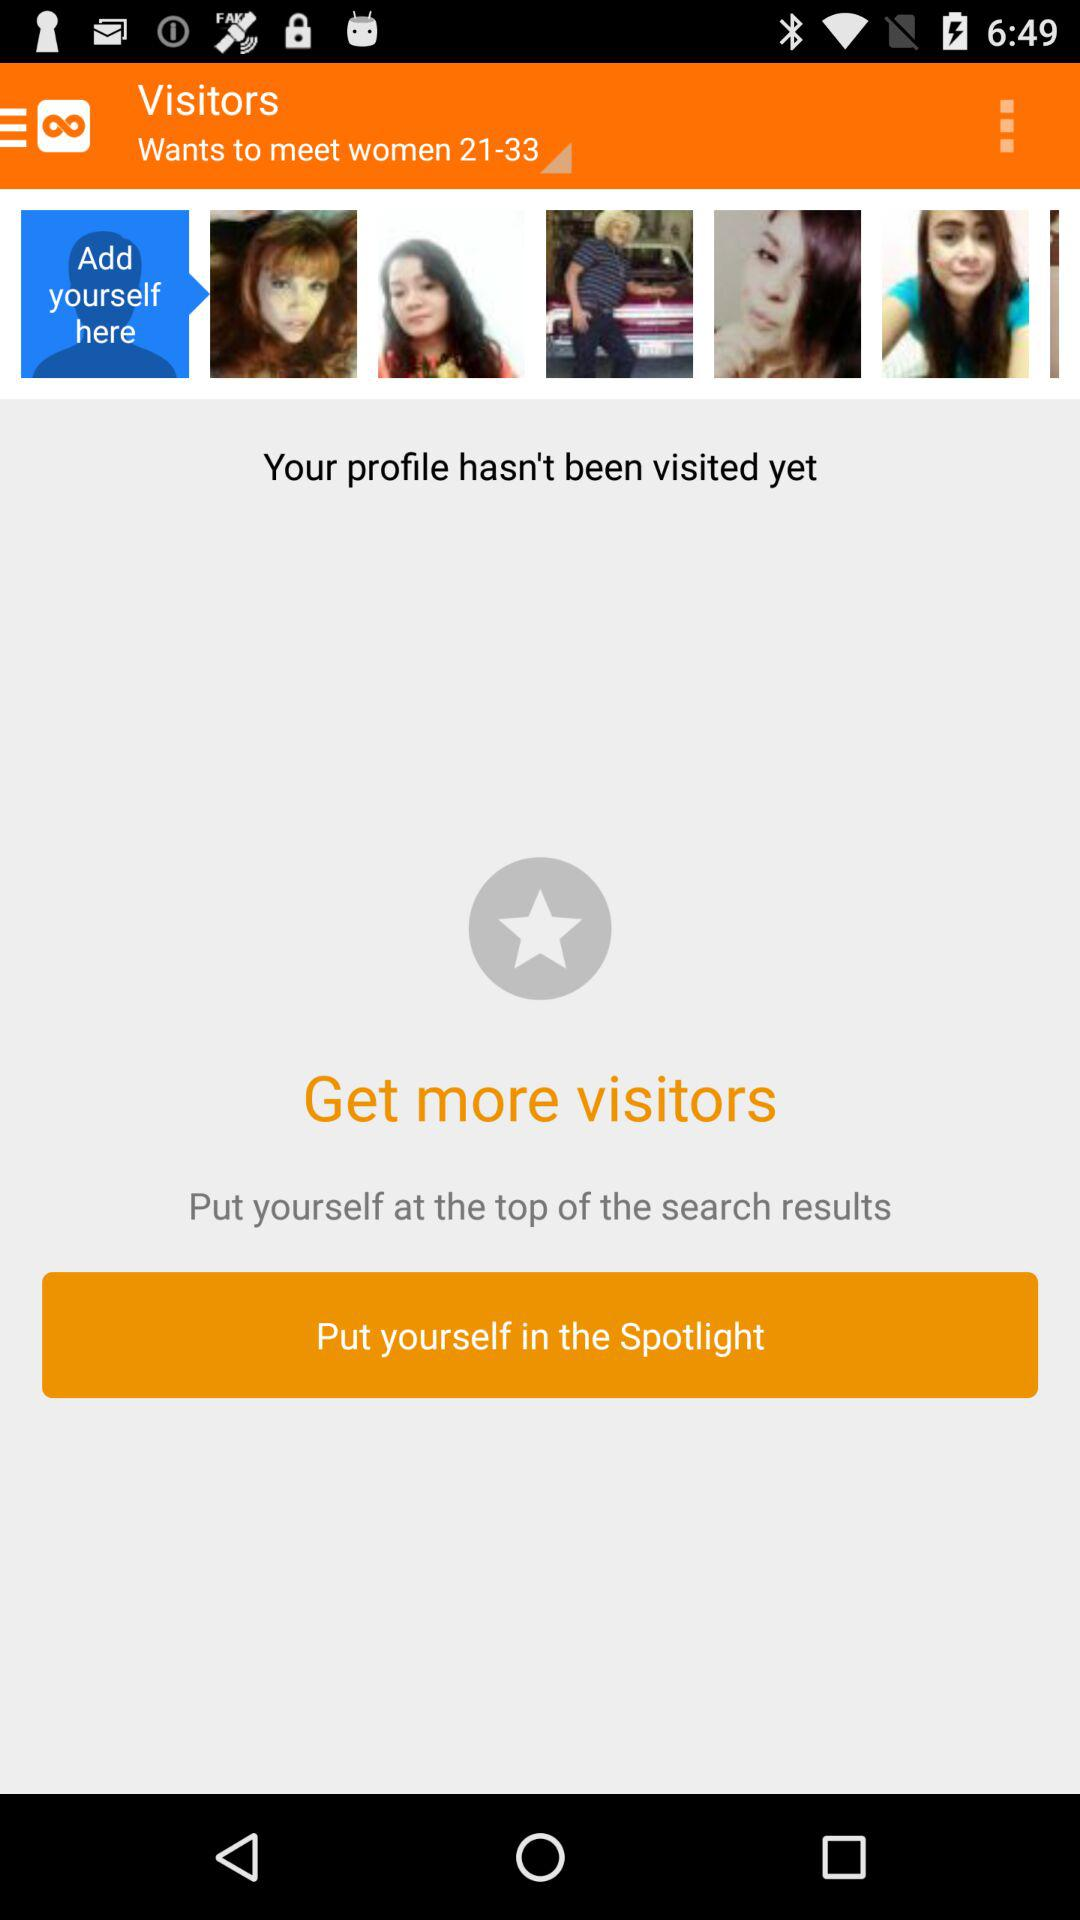What is the age range selected for women? The age range selected for women is from 21 to 33 years. 